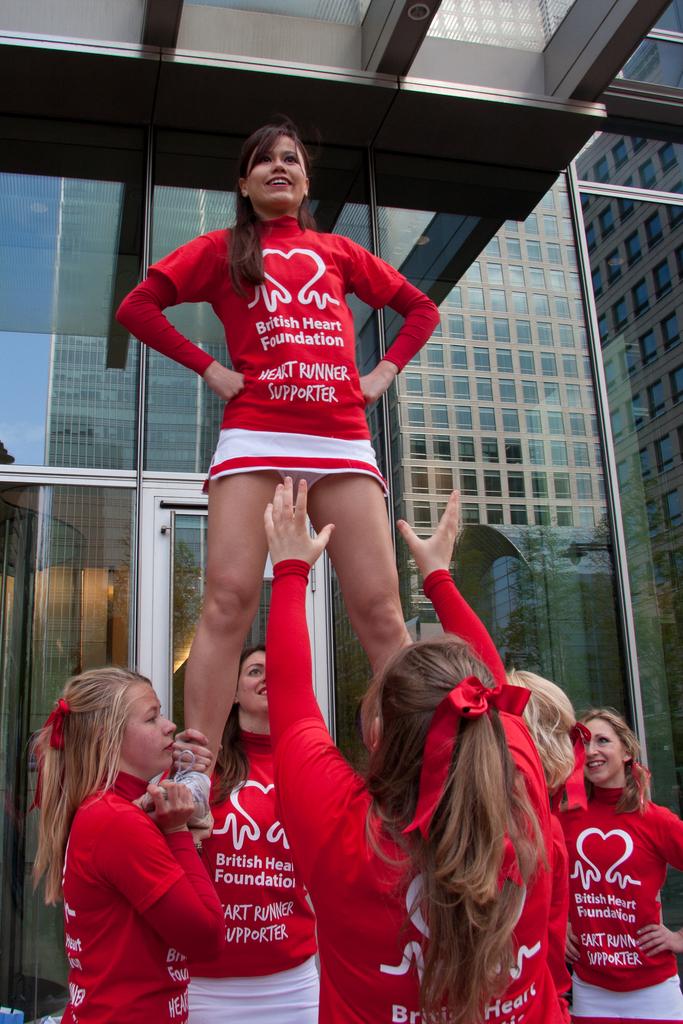What is the girl's role in the foundation?
Your answer should be very brief. Heart runner supporter. 